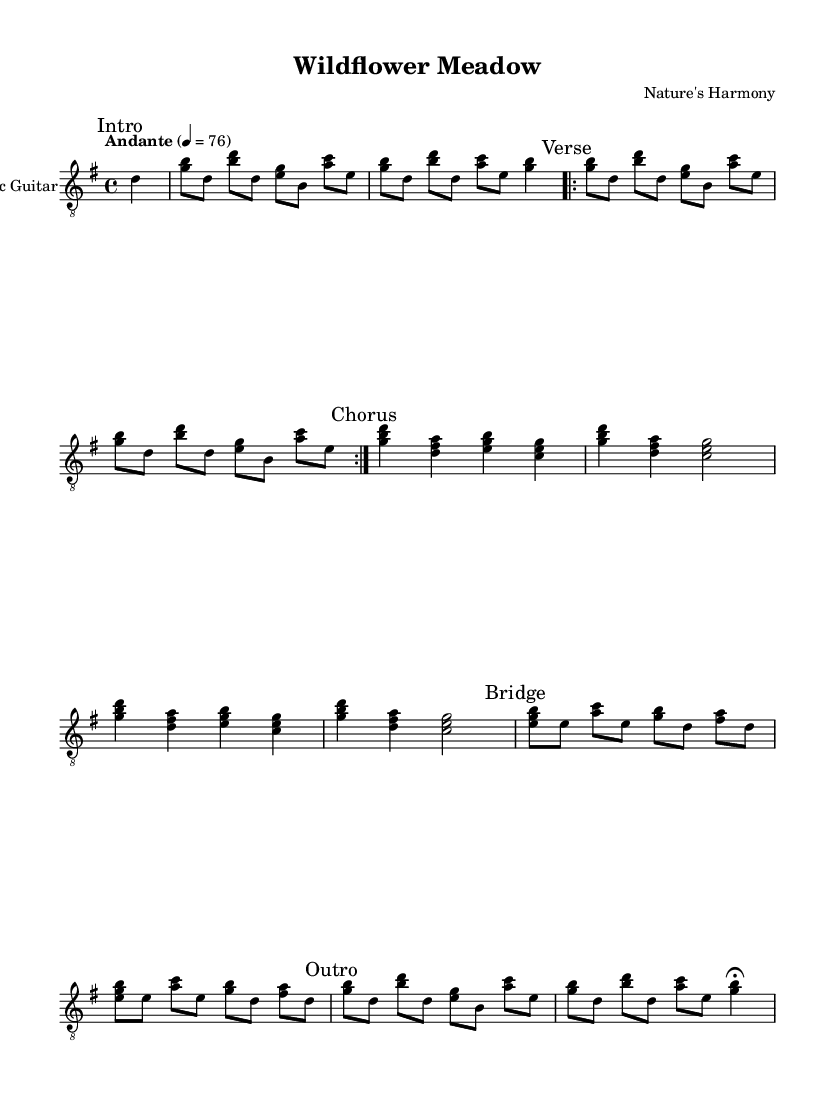What is the key signature of this music? The key signature is G major, which has one sharp (F#). This can be confirmed by looking at the key signature notation at the beginning of the sheet music, which indicates the notes that are sharp or flat throughout the piece.
Answer: G major What is the time signature of this music? The time signature is 4/4, meaning there are four beats in each measure and the quarter note gets one beat. This is indicated at the beginning of the sheet music next to the key signature.
Answer: 4/4 What is the tempo marking of this piece? The tempo marking is "Andante" at a speed of 76 beats per minute. This can be found at the start of the sheet music, specifying the pace at which the piece should be played.
Answer: Andante, 76 How many times is the first verse repeated? The first verse is repeated 2 times, which is indicated by the repeat volta markings that show it should play that section again.
Answer: 2 What is the structure of the song? The structure consists of an intro, verse, chorus, bridge, and outro, arranged sequentially as specified by the labeled sections in the sheet music. This layout provides a clear organization of the music's components.
Answer: Intro, Verse, Chorus, Bridge, Outro How many measures are in the chorus section? The chorus section has 4 measures, as counted from the printed music which shows each group of notes under the chorus heading, clearly marking the beginning and end of that section.
Answer: 4 What type of music does "Wildflower Meadow" represent? "Wildflower Meadow" represents a contemporary acoustic guitar ballad celebrating landscapes, as suggested by its title and the gentle characteristics of its melody and structure designed for acoustic guitar.
Answer: Contemporary acoustic guitar ballad 